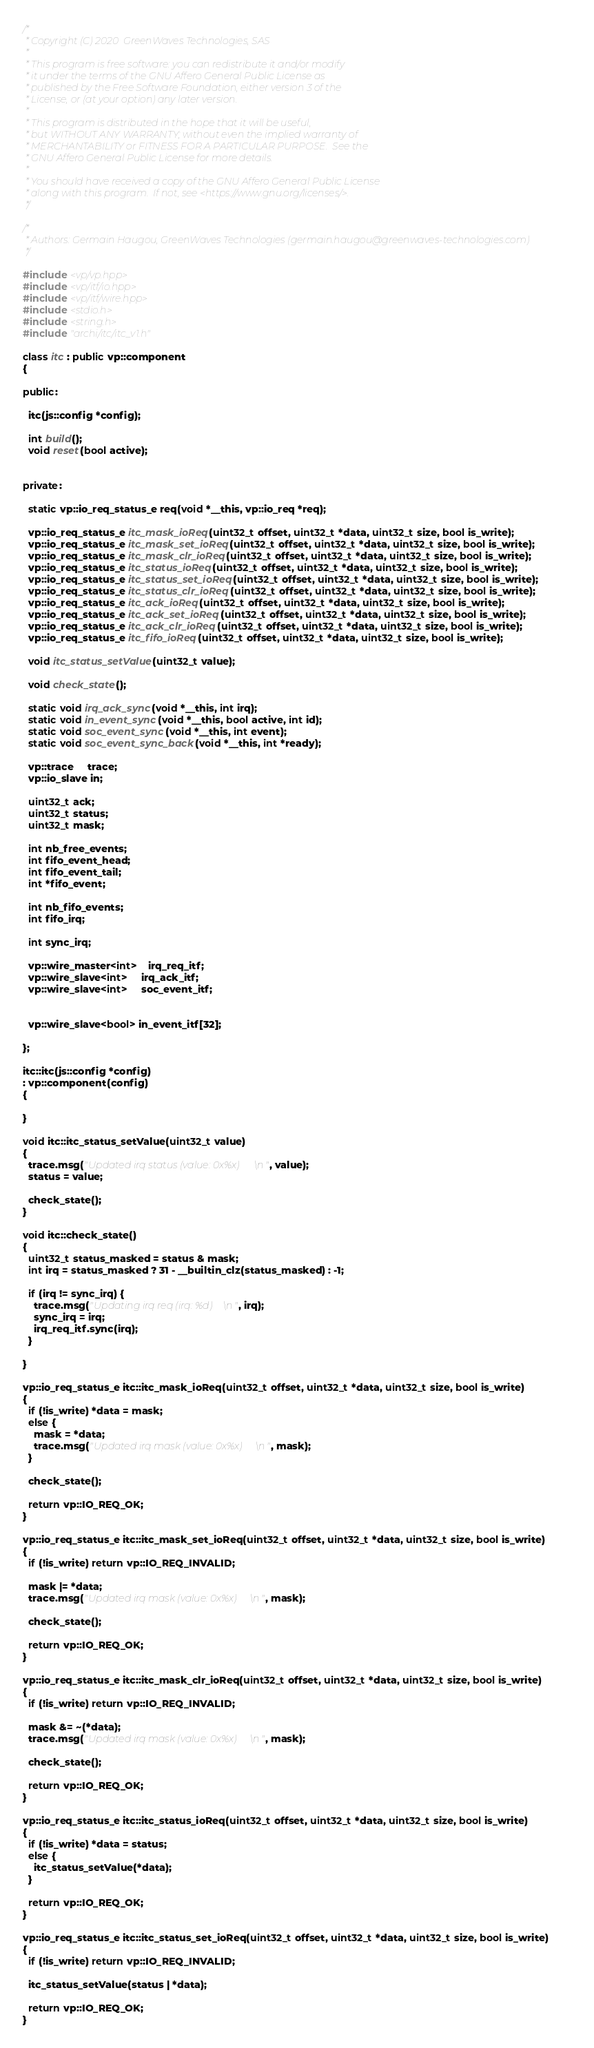<code> <loc_0><loc_0><loc_500><loc_500><_C++_>/*
 * Copyright (C) 2020  GreenWaves Technologies, SAS
 *
 * This program is free software: you can redistribute it and/or modify
 * it under the terms of the GNU Affero General Public License as
 * published by the Free Software Foundation, either version 3 of the
 * License, or (at your option) any later version.
 * 
 * This program is distributed in the hope that it will be useful,
 * but WITHOUT ANY WARRANTY; without even the implied warranty of
 * MERCHANTABILITY or FITNESS FOR A PARTICULAR PURPOSE.  See the
 * GNU Affero General Public License for more details.
 * 
 * You should have received a copy of the GNU Affero General Public License
 * along with this program.  If not, see <https://www.gnu.org/licenses/>.
 */

/* 
 * Authors: Germain Haugou, GreenWaves Technologies (germain.haugou@greenwaves-technologies.com)
 */

#include <vp/vp.hpp>
#include <vp/itf/io.hpp>
#include <vp/itf/wire.hpp>
#include <stdio.h>
#include <string.h>
#include "archi/itc/itc_v1.h"

class itc : public vp::component
{

public:

  itc(js::config *config);

  int build();
  void reset(bool active);


private:

  static vp::io_req_status_e req(void *__this, vp::io_req *req);

  vp::io_req_status_e itc_mask_ioReq(uint32_t offset, uint32_t *data, uint32_t size, bool is_write);
  vp::io_req_status_e itc_mask_set_ioReq(uint32_t offset, uint32_t *data, uint32_t size, bool is_write);
  vp::io_req_status_e itc_mask_clr_ioReq(uint32_t offset, uint32_t *data, uint32_t size, bool is_write);
  vp::io_req_status_e itc_status_ioReq(uint32_t offset, uint32_t *data, uint32_t size, bool is_write);
  vp::io_req_status_e itc_status_set_ioReq(uint32_t offset, uint32_t *data, uint32_t size, bool is_write);
  vp::io_req_status_e itc_status_clr_ioReq(uint32_t offset, uint32_t *data, uint32_t size, bool is_write);
  vp::io_req_status_e itc_ack_ioReq(uint32_t offset, uint32_t *data, uint32_t size, bool is_write);
  vp::io_req_status_e itc_ack_set_ioReq(uint32_t offset, uint32_t *data, uint32_t size, bool is_write);
  vp::io_req_status_e itc_ack_clr_ioReq(uint32_t offset, uint32_t *data, uint32_t size, bool is_write);
  vp::io_req_status_e itc_fifo_ioReq(uint32_t offset, uint32_t *data, uint32_t size, bool is_write);

  void itc_status_setValue(uint32_t value);

  void check_state();

  static void irq_ack_sync(void *__this, int irq);
  static void in_event_sync(void *__this, bool active, int id);
  static void soc_event_sync(void *__this, int event);
  static void soc_event_sync_back(void *__this, int *ready);

  vp::trace     trace;
  vp::io_slave in;

  uint32_t ack;
  uint32_t status;
  uint32_t mask;

  int nb_free_events;
  int fifo_event_head;
  int fifo_event_tail;
  int *fifo_event;

  int nb_fifo_events;
  int fifo_irq;

  int sync_irq;

  vp::wire_master<int>    irq_req_itf;
  vp::wire_slave<int>     irq_ack_itf;
  vp::wire_slave<int>     soc_event_itf;


  vp::wire_slave<bool> in_event_itf[32];

};

itc::itc(js::config *config)
: vp::component(config)
{

}

void itc::itc_status_setValue(uint32_t value)
{
  trace.msg("Updated irq status (value: 0x%x)\n", value);
  status = value;

  check_state();
}

void itc::check_state()
{
  uint32_t status_masked = status & mask;
  int irq = status_masked ? 31 - __builtin_clz(status_masked) : -1;

  if (irq != sync_irq) {
    trace.msg("Updating irq req (irq: %d)\n", irq);
    sync_irq = irq;
    irq_req_itf.sync(irq);
  }

}

vp::io_req_status_e itc::itc_mask_ioReq(uint32_t offset, uint32_t *data, uint32_t size, bool is_write)
{
  if (!is_write) *data = mask;
  else {
    mask = *data;
    trace.msg("Updated irq mask (value: 0x%x)\n", mask);
  }

  check_state();

  return vp::IO_REQ_OK;
}

vp::io_req_status_e itc::itc_mask_set_ioReq(uint32_t offset, uint32_t *data, uint32_t size, bool is_write)
{
  if (!is_write) return vp::IO_REQ_INVALID;

  mask |= *data;
  trace.msg("Updated irq mask (value: 0x%x)\n", mask);

  check_state();
  
  return vp::IO_REQ_OK;
}

vp::io_req_status_e itc::itc_mask_clr_ioReq(uint32_t offset, uint32_t *data, uint32_t size, bool is_write)
{
  if (!is_write) return vp::IO_REQ_INVALID;

  mask &= ~(*data);
  trace.msg("Updated irq mask (value: 0x%x)\n", mask);

  check_state();
  
  return vp::IO_REQ_OK;
}

vp::io_req_status_e itc::itc_status_ioReq(uint32_t offset, uint32_t *data, uint32_t size, bool is_write)
{
  if (!is_write) *data = status;
  else {
    itc_status_setValue(*data);
  }

  return vp::IO_REQ_OK;
}

vp::io_req_status_e itc::itc_status_set_ioReq(uint32_t offset, uint32_t *data, uint32_t size, bool is_write)
{
  if (!is_write) return vp::IO_REQ_INVALID;

  itc_status_setValue(status | *data);

  return vp::IO_REQ_OK;
}
</code> 